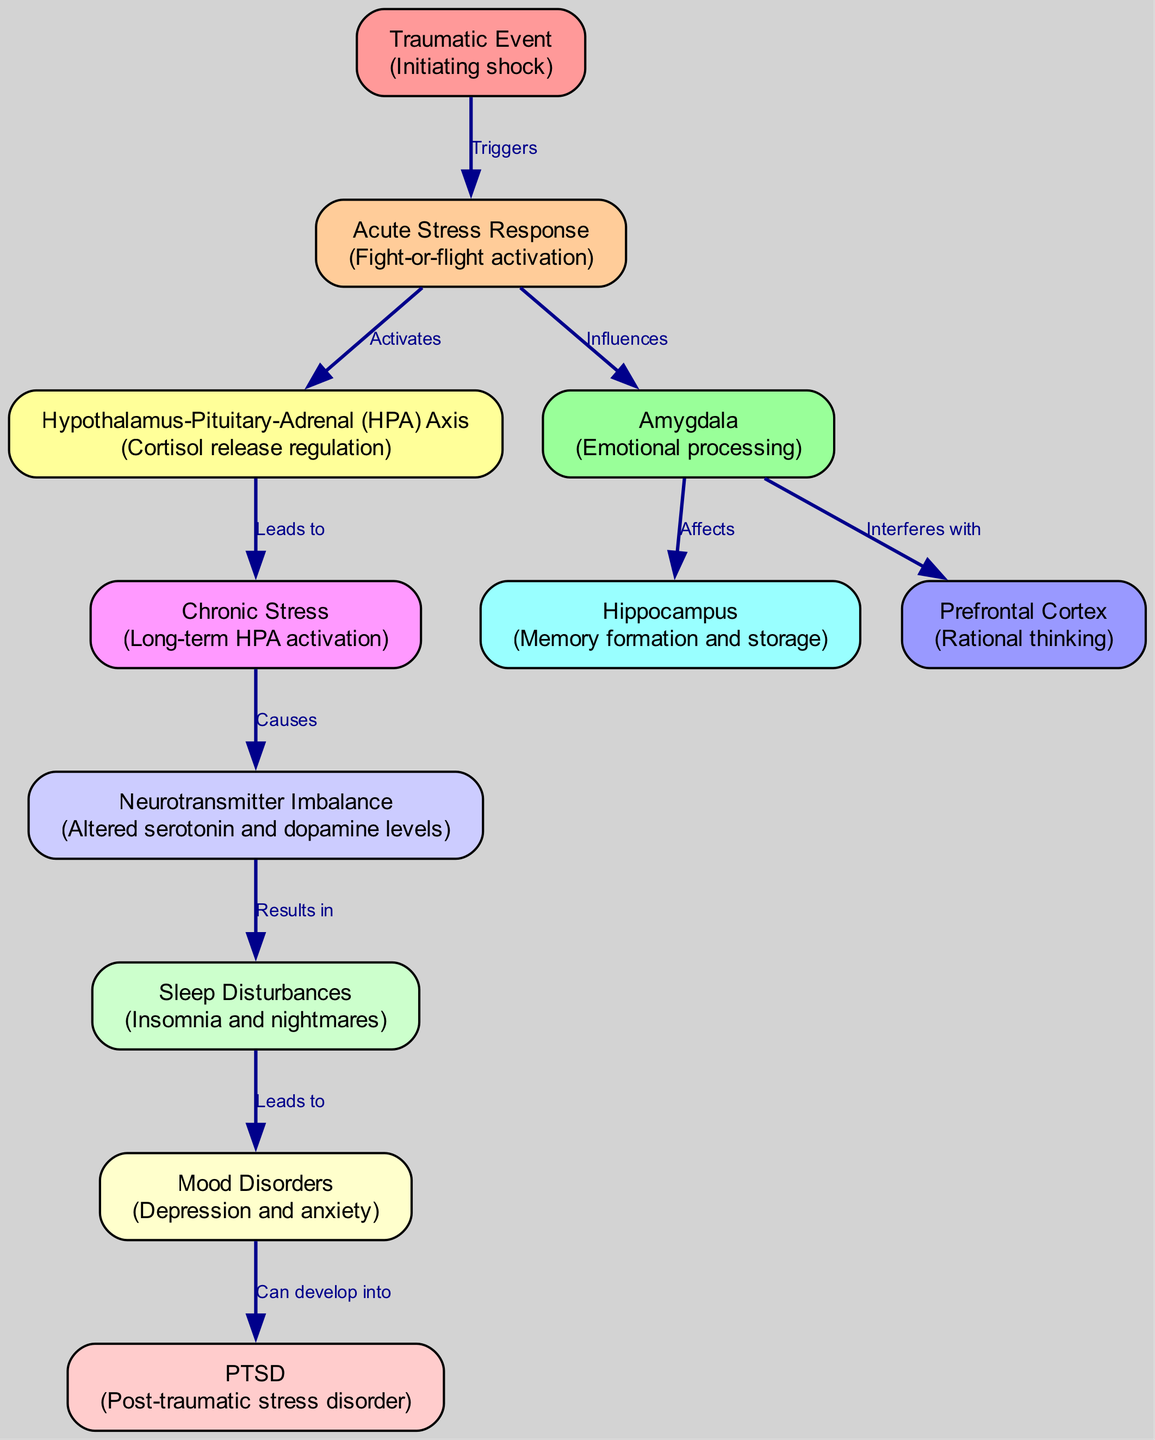What is the first node in the diagram? The first node, as indicated by its position and the label, is "Traumatic Event". This node serves as the starting point of the schematic, representing the initial shock.
Answer: Traumatic Event How many edges are there in total? By counting the lines connecting the nodes, we find that there are 10 edges that illustrate the relationships between the nodes.
Answer: 10 What effect does the Amygdala have on the Hippocampus? The diagram indicates that the Amygdala "Affects" the Hippocampus, showing a direct influence from the emotional processing to memory formation and storage.
Answer: Affects Which node is responsible for "Cortisol release regulation"? The node labeled "Hypothalamus-Pituitary-Adrenal (HPA) Axis" is responsible for regulating cortisol release, as stated in its description.
Answer: Hypothalamus-Pituitary-Adrenal (HPA) Axis What develops from Mood Disorders? The diagram shows that "Mood Disorders" can develop into "PTSD", indicating a sequential relationship where mood-related issues may lead to post-traumatic stress disorder.
Answer: PTSD Which node is activated by Acute Stress Response? The "Hypothalamus-Pituitary-Adrenal (HPA) Axis" is activated by the "Acute Stress Response". This indicates a direct relationship where stress triggers this regulatory axis.
Answer: Hypothalamus-Pituitary-Adrenal (HPA) Axis What results from Neurotransmitter Imbalance? "Sleep Disturbances" result from a "Neurotransmitter Imbalance", suggesting that changes in neurotransmitter levels can lead to issues like insomnia and nightmares.
Answer: Sleep Disturbances What is the primary function of the Prefrontal Cortex? The primary function of the Prefrontal Cortex as described is "Rational thinking", indicating its role in higher cognitive processes.
Answer: Rational thinking What can Chronic Stress cause? "Neurotransmitter Imbalance" is caused by "Chronic Stress", which shows how long-term activation of stress responses can alter neurotransmitter levels.
Answer: Neurotransmitter Imbalance 